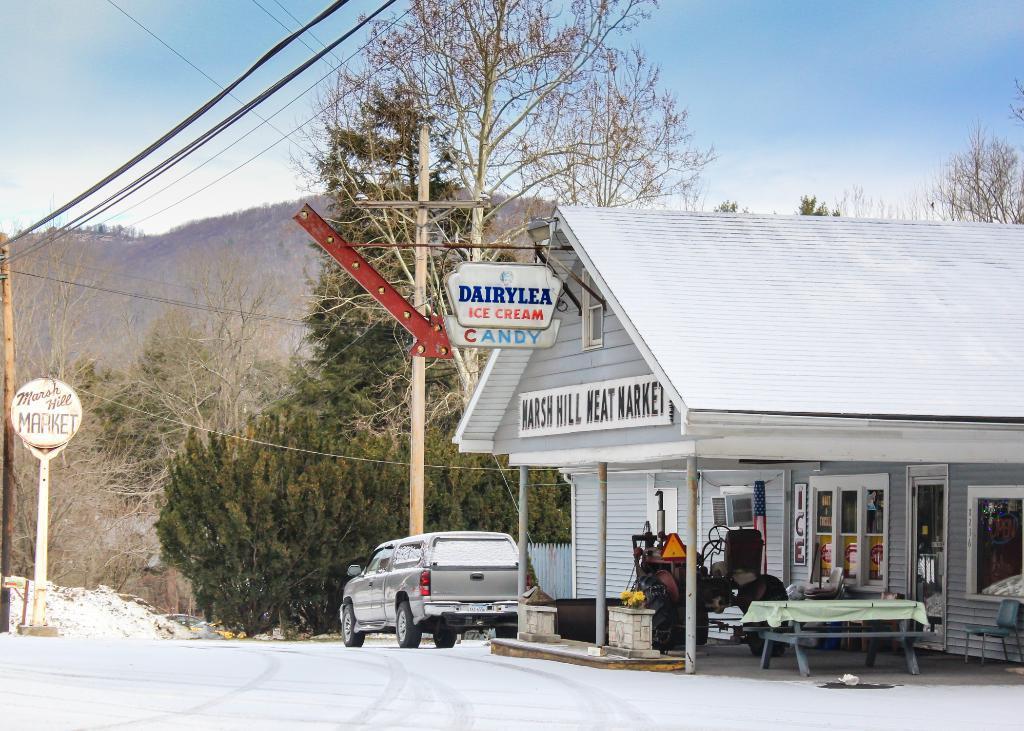Can you describe this image briefly? In the image we can see one house,table,vehicle,car,pole and it was named as "Dairy Ice cream". On the left we can see sign board. And coming to background we can see three,ski,hill. 